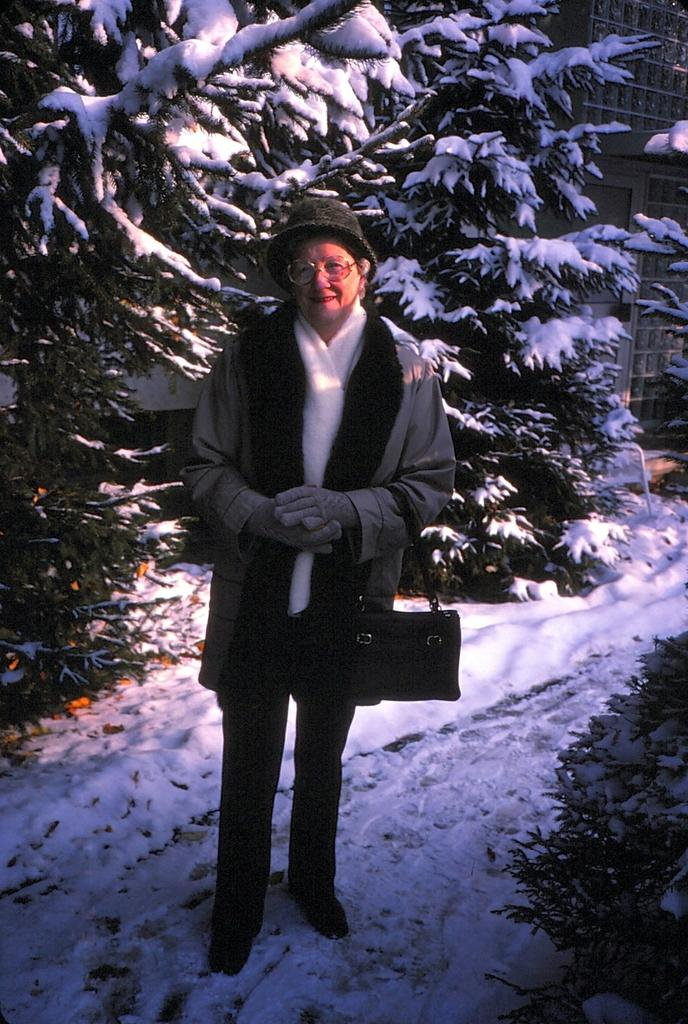What is the main subject of the image? There is a person standing in the image. Can you describe the person's attire? The person is wearing a hat. What is the natural environment like in the image? There are trees covered with snow in the image. What can be seen in the background of the image? There is a building visible in the background of the image. How many units are required to join the land in the image? There is no mention of units or joining land in the image; it simply shows a person standing, snow-covered trees, and a building in the background. 